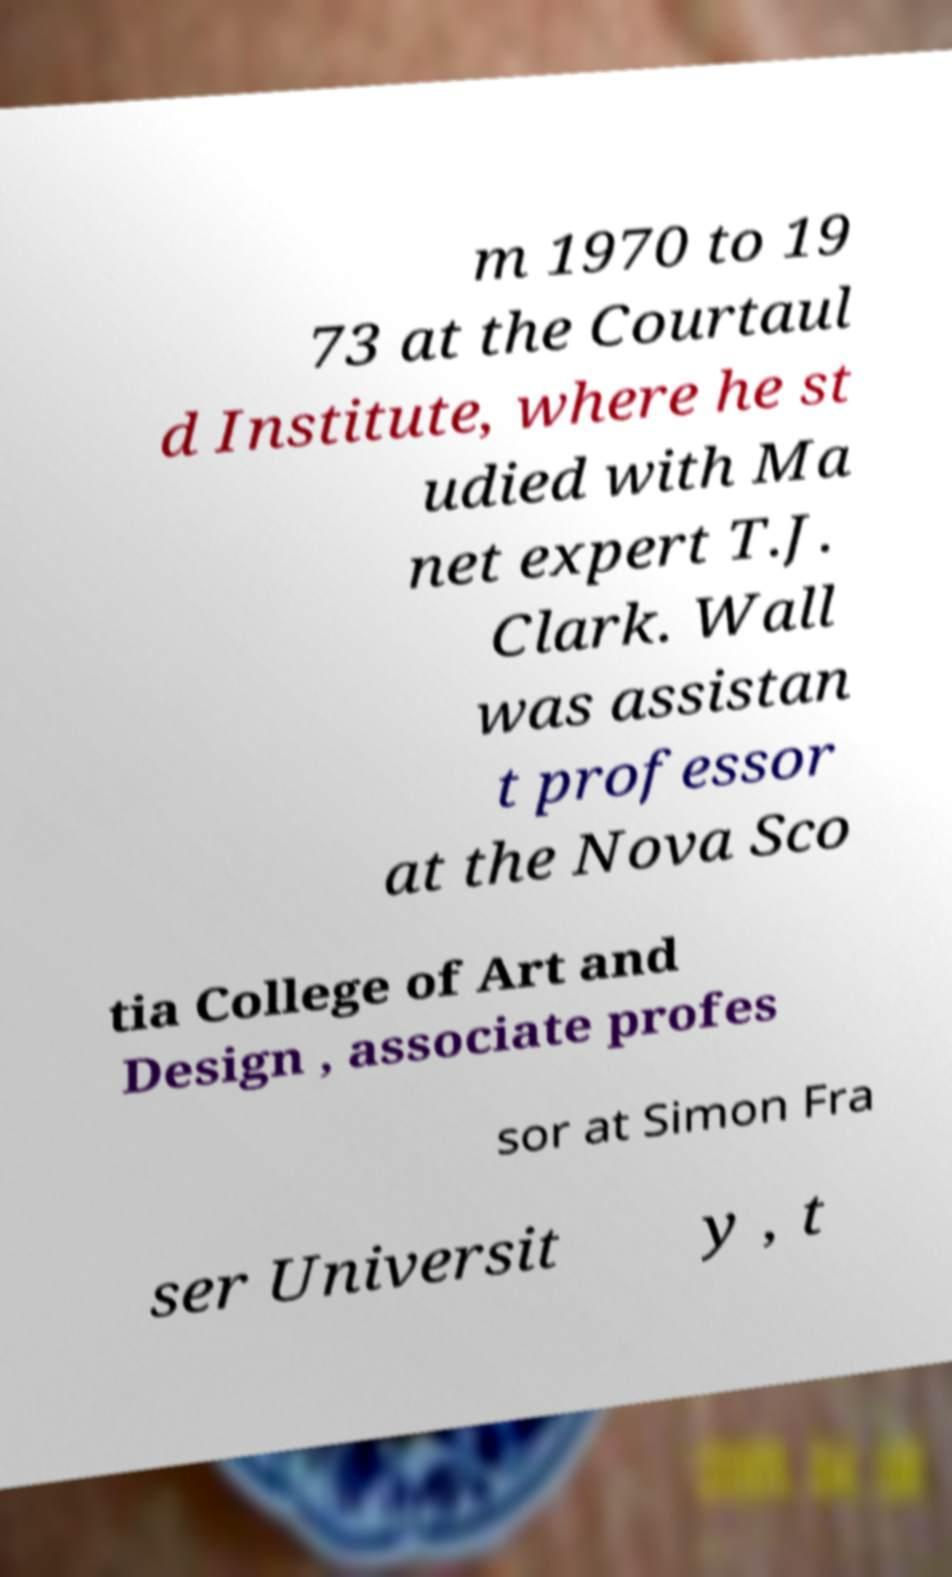What messages or text are displayed in this image? I need them in a readable, typed format. m 1970 to 19 73 at the Courtaul d Institute, where he st udied with Ma net expert T.J. Clark. Wall was assistan t professor at the Nova Sco tia College of Art and Design , associate profes sor at Simon Fra ser Universit y , t 